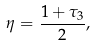<formula> <loc_0><loc_0><loc_500><loc_500>\eta = \frac { 1 + \tau _ { 3 } } { 2 } ,</formula> 